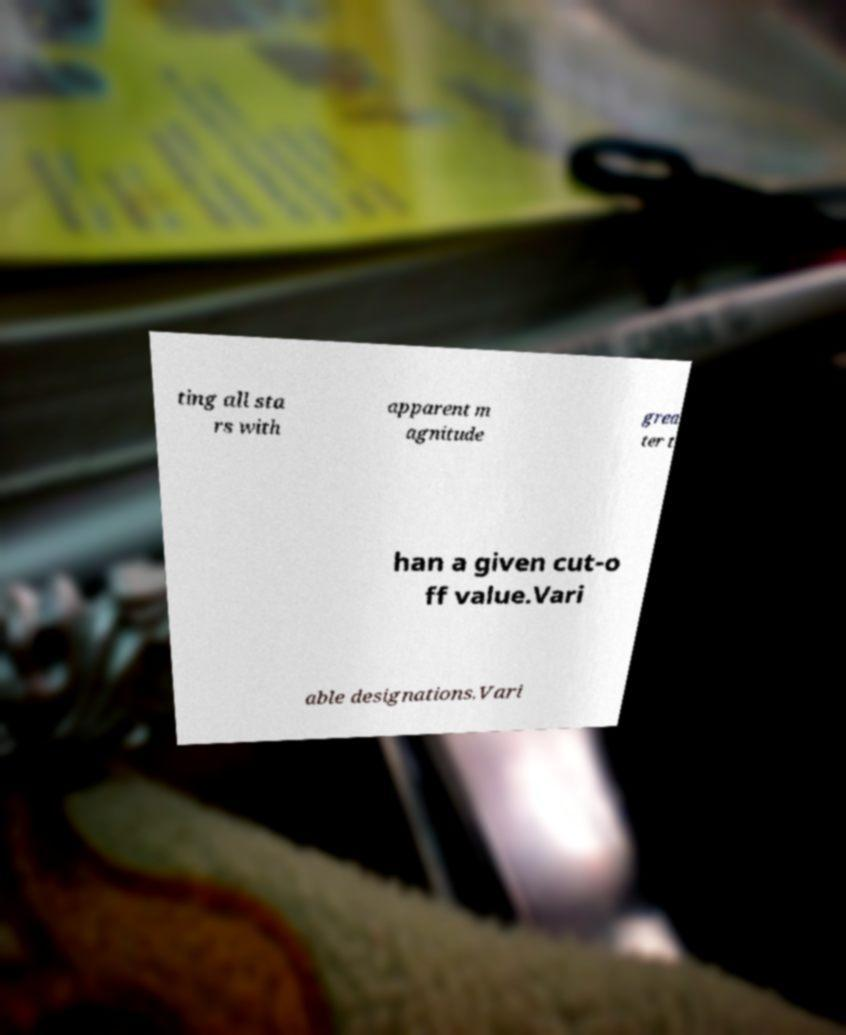Could you extract and type out the text from this image? ting all sta rs with apparent m agnitude grea ter t han a given cut-o ff value.Vari able designations.Vari 